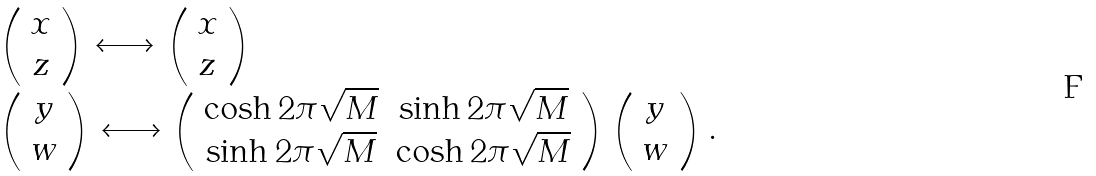Convert formula to latex. <formula><loc_0><loc_0><loc_500><loc_500>\begin{array} { l } \left ( \begin{array} { c } x \\ z \end{array} \right ) \longleftrightarrow \left ( \begin{array} { c } x \\ z \end{array} \right ) \\ \left ( \begin{array} { c } y \\ w \end{array} \right ) \longleftrightarrow \left ( \begin{array} { c c } \cosh 2 \pi \sqrt { M } & \sinh 2 \pi \sqrt { M } \\ \sinh 2 \pi \sqrt { M } & \cosh 2 \pi \sqrt { M } \\ \end{array} \right ) \left ( \begin{array} { c } y \\ w \end{array} \right ) . \end{array}</formula> 